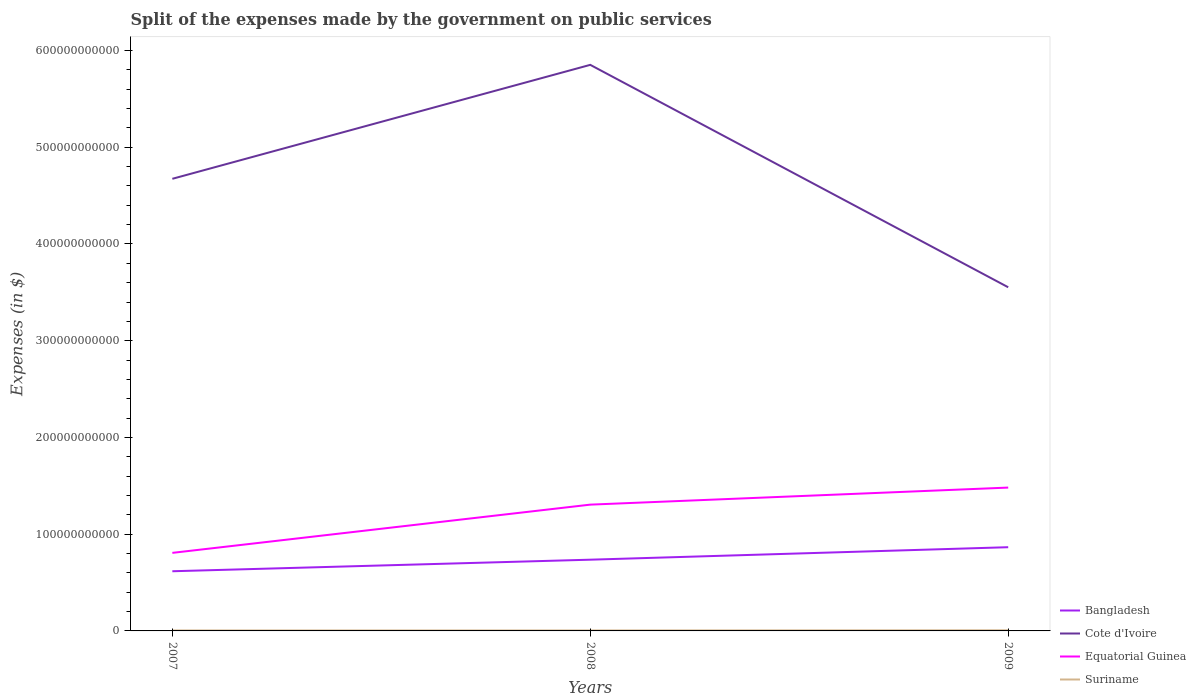How many different coloured lines are there?
Provide a succinct answer. 4. Does the line corresponding to Bangladesh intersect with the line corresponding to Cote d'Ivoire?
Your response must be concise. No. Across all years, what is the maximum expenses made by the government on public services in Bangladesh?
Make the answer very short. 6.17e+1. What is the total expenses made by the government on public services in Cote d'Ivoire in the graph?
Your answer should be very brief. 2.30e+11. What is the difference between the highest and the second highest expenses made by the government on public services in Equatorial Guinea?
Your response must be concise. 6.75e+1. How many years are there in the graph?
Your answer should be very brief. 3. What is the difference between two consecutive major ticks on the Y-axis?
Ensure brevity in your answer.  1.00e+11. Are the values on the major ticks of Y-axis written in scientific E-notation?
Make the answer very short. No. Does the graph contain any zero values?
Your answer should be compact. No. Does the graph contain grids?
Provide a short and direct response. No. Where does the legend appear in the graph?
Make the answer very short. Bottom right. What is the title of the graph?
Offer a very short reply. Split of the expenses made by the government on public services. Does "Luxembourg" appear as one of the legend labels in the graph?
Make the answer very short. No. What is the label or title of the Y-axis?
Your response must be concise. Expenses (in $). What is the Expenses (in $) of Bangladesh in 2007?
Offer a terse response. 6.17e+1. What is the Expenses (in $) of Cote d'Ivoire in 2007?
Provide a succinct answer. 4.67e+11. What is the Expenses (in $) in Equatorial Guinea in 2007?
Ensure brevity in your answer.  8.07e+1. What is the Expenses (in $) of Suriname in 2007?
Offer a terse response. 4.81e+08. What is the Expenses (in $) of Bangladesh in 2008?
Give a very brief answer. 7.36e+1. What is the Expenses (in $) in Cote d'Ivoire in 2008?
Your response must be concise. 5.85e+11. What is the Expenses (in $) in Equatorial Guinea in 2008?
Your response must be concise. 1.31e+11. What is the Expenses (in $) in Suriname in 2008?
Your response must be concise. 4.88e+08. What is the Expenses (in $) in Bangladesh in 2009?
Give a very brief answer. 8.66e+1. What is the Expenses (in $) in Cote d'Ivoire in 2009?
Your response must be concise. 3.55e+11. What is the Expenses (in $) in Equatorial Guinea in 2009?
Ensure brevity in your answer.  1.48e+11. What is the Expenses (in $) of Suriname in 2009?
Your response must be concise. 6.52e+08. Across all years, what is the maximum Expenses (in $) of Bangladesh?
Give a very brief answer. 8.66e+1. Across all years, what is the maximum Expenses (in $) of Cote d'Ivoire?
Ensure brevity in your answer.  5.85e+11. Across all years, what is the maximum Expenses (in $) in Equatorial Guinea?
Your response must be concise. 1.48e+11. Across all years, what is the maximum Expenses (in $) of Suriname?
Provide a short and direct response. 6.52e+08. Across all years, what is the minimum Expenses (in $) in Bangladesh?
Make the answer very short. 6.17e+1. Across all years, what is the minimum Expenses (in $) of Cote d'Ivoire?
Your answer should be compact. 3.55e+11. Across all years, what is the minimum Expenses (in $) of Equatorial Guinea?
Your answer should be compact. 8.07e+1. Across all years, what is the minimum Expenses (in $) in Suriname?
Keep it short and to the point. 4.81e+08. What is the total Expenses (in $) of Bangladesh in the graph?
Provide a succinct answer. 2.22e+11. What is the total Expenses (in $) in Cote d'Ivoire in the graph?
Ensure brevity in your answer.  1.41e+12. What is the total Expenses (in $) of Equatorial Guinea in the graph?
Offer a very short reply. 3.59e+11. What is the total Expenses (in $) of Suriname in the graph?
Offer a very short reply. 1.62e+09. What is the difference between the Expenses (in $) of Bangladesh in 2007 and that in 2008?
Provide a succinct answer. -1.20e+1. What is the difference between the Expenses (in $) of Cote d'Ivoire in 2007 and that in 2008?
Offer a terse response. -1.18e+11. What is the difference between the Expenses (in $) in Equatorial Guinea in 2007 and that in 2008?
Offer a very short reply. -4.99e+1. What is the difference between the Expenses (in $) of Suriname in 2007 and that in 2008?
Your answer should be compact. -7.24e+06. What is the difference between the Expenses (in $) in Bangladesh in 2007 and that in 2009?
Offer a very short reply. -2.49e+1. What is the difference between the Expenses (in $) in Cote d'Ivoire in 2007 and that in 2009?
Keep it short and to the point. 1.12e+11. What is the difference between the Expenses (in $) of Equatorial Guinea in 2007 and that in 2009?
Offer a terse response. -6.75e+1. What is the difference between the Expenses (in $) in Suriname in 2007 and that in 2009?
Your answer should be compact. -1.71e+08. What is the difference between the Expenses (in $) of Bangladesh in 2008 and that in 2009?
Ensure brevity in your answer.  -1.29e+1. What is the difference between the Expenses (in $) in Cote d'Ivoire in 2008 and that in 2009?
Give a very brief answer. 2.30e+11. What is the difference between the Expenses (in $) in Equatorial Guinea in 2008 and that in 2009?
Ensure brevity in your answer.  -1.76e+1. What is the difference between the Expenses (in $) in Suriname in 2008 and that in 2009?
Offer a very short reply. -1.64e+08. What is the difference between the Expenses (in $) of Bangladesh in 2007 and the Expenses (in $) of Cote d'Ivoire in 2008?
Provide a short and direct response. -5.24e+11. What is the difference between the Expenses (in $) of Bangladesh in 2007 and the Expenses (in $) of Equatorial Guinea in 2008?
Ensure brevity in your answer.  -6.89e+1. What is the difference between the Expenses (in $) of Bangladesh in 2007 and the Expenses (in $) of Suriname in 2008?
Provide a short and direct response. 6.12e+1. What is the difference between the Expenses (in $) in Cote d'Ivoire in 2007 and the Expenses (in $) in Equatorial Guinea in 2008?
Offer a very short reply. 3.37e+11. What is the difference between the Expenses (in $) in Cote d'Ivoire in 2007 and the Expenses (in $) in Suriname in 2008?
Your answer should be compact. 4.67e+11. What is the difference between the Expenses (in $) in Equatorial Guinea in 2007 and the Expenses (in $) in Suriname in 2008?
Keep it short and to the point. 8.02e+1. What is the difference between the Expenses (in $) in Bangladesh in 2007 and the Expenses (in $) in Cote d'Ivoire in 2009?
Make the answer very short. -2.94e+11. What is the difference between the Expenses (in $) of Bangladesh in 2007 and the Expenses (in $) of Equatorial Guinea in 2009?
Provide a short and direct response. -8.65e+1. What is the difference between the Expenses (in $) of Bangladesh in 2007 and the Expenses (in $) of Suriname in 2009?
Your answer should be very brief. 6.10e+1. What is the difference between the Expenses (in $) in Cote d'Ivoire in 2007 and the Expenses (in $) in Equatorial Guinea in 2009?
Your response must be concise. 3.19e+11. What is the difference between the Expenses (in $) of Cote d'Ivoire in 2007 and the Expenses (in $) of Suriname in 2009?
Keep it short and to the point. 4.67e+11. What is the difference between the Expenses (in $) of Equatorial Guinea in 2007 and the Expenses (in $) of Suriname in 2009?
Offer a very short reply. 8.00e+1. What is the difference between the Expenses (in $) of Bangladesh in 2008 and the Expenses (in $) of Cote d'Ivoire in 2009?
Your answer should be compact. -2.82e+11. What is the difference between the Expenses (in $) of Bangladesh in 2008 and the Expenses (in $) of Equatorial Guinea in 2009?
Offer a terse response. -7.45e+1. What is the difference between the Expenses (in $) of Bangladesh in 2008 and the Expenses (in $) of Suriname in 2009?
Provide a succinct answer. 7.30e+1. What is the difference between the Expenses (in $) in Cote d'Ivoire in 2008 and the Expenses (in $) in Equatorial Guinea in 2009?
Your answer should be very brief. 4.37e+11. What is the difference between the Expenses (in $) of Cote d'Ivoire in 2008 and the Expenses (in $) of Suriname in 2009?
Make the answer very short. 5.85e+11. What is the difference between the Expenses (in $) of Equatorial Guinea in 2008 and the Expenses (in $) of Suriname in 2009?
Provide a succinct answer. 1.30e+11. What is the average Expenses (in $) of Bangladesh per year?
Offer a terse response. 7.40e+1. What is the average Expenses (in $) of Cote d'Ivoire per year?
Keep it short and to the point. 4.69e+11. What is the average Expenses (in $) of Equatorial Guinea per year?
Provide a short and direct response. 1.20e+11. What is the average Expenses (in $) in Suriname per year?
Keep it short and to the point. 5.40e+08. In the year 2007, what is the difference between the Expenses (in $) in Bangladesh and Expenses (in $) in Cote d'Ivoire?
Provide a succinct answer. -4.06e+11. In the year 2007, what is the difference between the Expenses (in $) in Bangladesh and Expenses (in $) in Equatorial Guinea?
Give a very brief answer. -1.90e+1. In the year 2007, what is the difference between the Expenses (in $) of Bangladesh and Expenses (in $) of Suriname?
Offer a terse response. 6.12e+1. In the year 2007, what is the difference between the Expenses (in $) in Cote d'Ivoire and Expenses (in $) in Equatorial Guinea?
Give a very brief answer. 3.87e+11. In the year 2007, what is the difference between the Expenses (in $) in Cote d'Ivoire and Expenses (in $) in Suriname?
Your answer should be compact. 4.67e+11. In the year 2007, what is the difference between the Expenses (in $) in Equatorial Guinea and Expenses (in $) in Suriname?
Offer a terse response. 8.02e+1. In the year 2008, what is the difference between the Expenses (in $) in Bangladesh and Expenses (in $) in Cote d'Ivoire?
Make the answer very short. -5.12e+11. In the year 2008, what is the difference between the Expenses (in $) of Bangladesh and Expenses (in $) of Equatorial Guinea?
Offer a very short reply. -5.69e+1. In the year 2008, what is the difference between the Expenses (in $) in Bangladesh and Expenses (in $) in Suriname?
Provide a succinct answer. 7.32e+1. In the year 2008, what is the difference between the Expenses (in $) in Cote d'Ivoire and Expenses (in $) in Equatorial Guinea?
Offer a terse response. 4.55e+11. In the year 2008, what is the difference between the Expenses (in $) of Cote d'Ivoire and Expenses (in $) of Suriname?
Offer a very short reply. 5.85e+11. In the year 2008, what is the difference between the Expenses (in $) of Equatorial Guinea and Expenses (in $) of Suriname?
Keep it short and to the point. 1.30e+11. In the year 2009, what is the difference between the Expenses (in $) of Bangladesh and Expenses (in $) of Cote d'Ivoire?
Offer a very short reply. -2.69e+11. In the year 2009, what is the difference between the Expenses (in $) in Bangladesh and Expenses (in $) in Equatorial Guinea?
Make the answer very short. -6.16e+1. In the year 2009, what is the difference between the Expenses (in $) of Bangladesh and Expenses (in $) of Suriname?
Your answer should be compact. 8.59e+1. In the year 2009, what is the difference between the Expenses (in $) in Cote d'Ivoire and Expenses (in $) in Equatorial Guinea?
Make the answer very short. 2.07e+11. In the year 2009, what is the difference between the Expenses (in $) in Cote d'Ivoire and Expenses (in $) in Suriname?
Provide a succinct answer. 3.55e+11. In the year 2009, what is the difference between the Expenses (in $) in Equatorial Guinea and Expenses (in $) in Suriname?
Your answer should be very brief. 1.48e+11. What is the ratio of the Expenses (in $) in Bangladesh in 2007 to that in 2008?
Give a very brief answer. 0.84. What is the ratio of the Expenses (in $) in Cote d'Ivoire in 2007 to that in 2008?
Offer a very short reply. 0.8. What is the ratio of the Expenses (in $) of Equatorial Guinea in 2007 to that in 2008?
Keep it short and to the point. 0.62. What is the ratio of the Expenses (in $) of Suriname in 2007 to that in 2008?
Ensure brevity in your answer.  0.99. What is the ratio of the Expenses (in $) of Bangladesh in 2007 to that in 2009?
Your answer should be very brief. 0.71. What is the ratio of the Expenses (in $) of Cote d'Ivoire in 2007 to that in 2009?
Provide a short and direct response. 1.32. What is the ratio of the Expenses (in $) of Equatorial Guinea in 2007 to that in 2009?
Your answer should be very brief. 0.54. What is the ratio of the Expenses (in $) in Suriname in 2007 to that in 2009?
Your answer should be compact. 0.74. What is the ratio of the Expenses (in $) in Bangladesh in 2008 to that in 2009?
Give a very brief answer. 0.85. What is the ratio of the Expenses (in $) in Cote d'Ivoire in 2008 to that in 2009?
Provide a short and direct response. 1.65. What is the ratio of the Expenses (in $) of Equatorial Guinea in 2008 to that in 2009?
Ensure brevity in your answer.  0.88. What is the ratio of the Expenses (in $) in Suriname in 2008 to that in 2009?
Your answer should be very brief. 0.75. What is the difference between the highest and the second highest Expenses (in $) in Bangladesh?
Keep it short and to the point. 1.29e+1. What is the difference between the highest and the second highest Expenses (in $) of Cote d'Ivoire?
Provide a short and direct response. 1.18e+11. What is the difference between the highest and the second highest Expenses (in $) in Equatorial Guinea?
Keep it short and to the point. 1.76e+1. What is the difference between the highest and the second highest Expenses (in $) in Suriname?
Give a very brief answer. 1.64e+08. What is the difference between the highest and the lowest Expenses (in $) in Bangladesh?
Ensure brevity in your answer.  2.49e+1. What is the difference between the highest and the lowest Expenses (in $) of Cote d'Ivoire?
Provide a short and direct response. 2.30e+11. What is the difference between the highest and the lowest Expenses (in $) in Equatorial Guinea?
Your response must be concise. 6.75e+1. What is the difference between the highest and the lowest Expenses (in $) in Suriname?
Your answer should be very brief. 1.71e+08. 